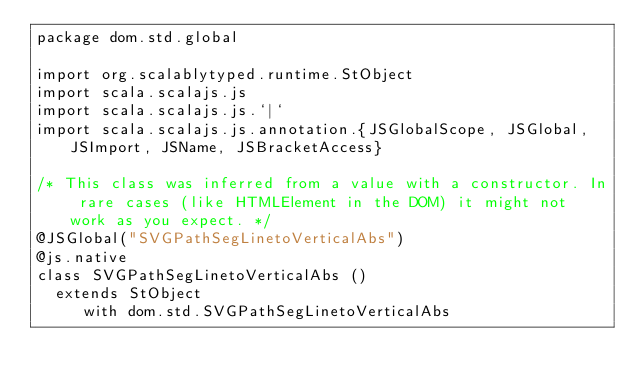<code> <loc_0><loc_0><loc_500><loc_500><_Scala_>package dom.std.global

import org.scalablytyped.runtime.StObject
import scala.scalajs.js
import scala.scalajs.js.`|`
import scala.scalajs.js.annotation.{JSGlobalScope, JSGlobal, JSImport, JSName, JSBracketAccess}

/* This class was inferred from a value with a constructor. In rare cases (like HTMLElement in the DOM) it might not work as you expect. */
@JSGlobal("SVGPathSegLinetoVerticalAbs")
@js.native
class SVGPathSegLinetoVerticalAbs ()
  extends StObject
     with dom.std.SVGPathSegLinetoVerticalAbs
</code> 